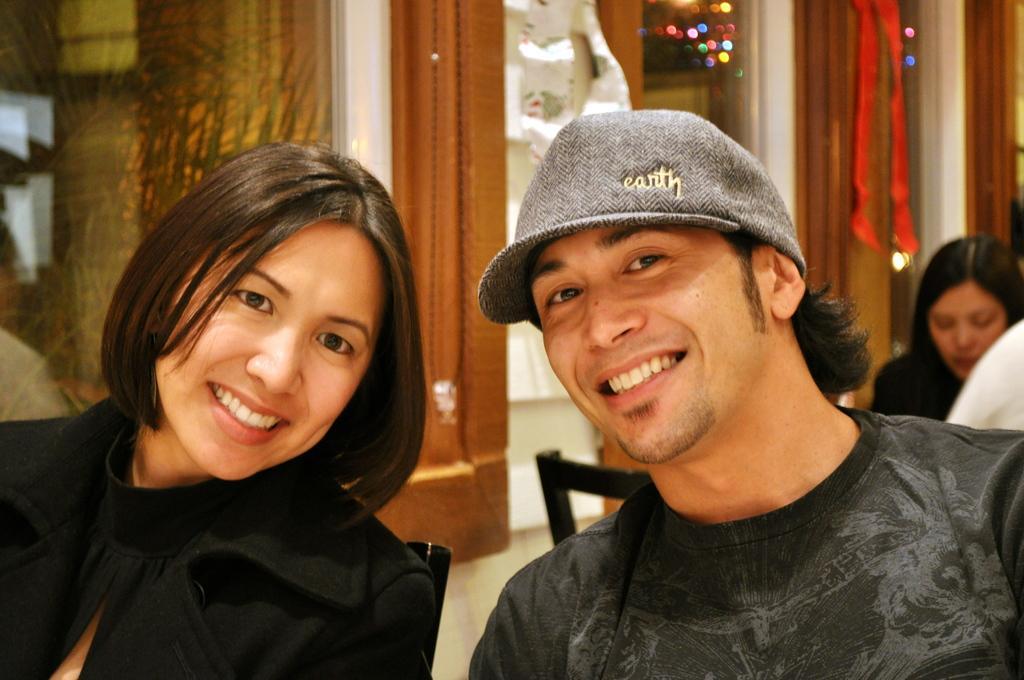How would you summarize this image in a sentence or two? In this image we can see a few people sitting on the chairs, behind them, we can see a building with windows and some other objects. 